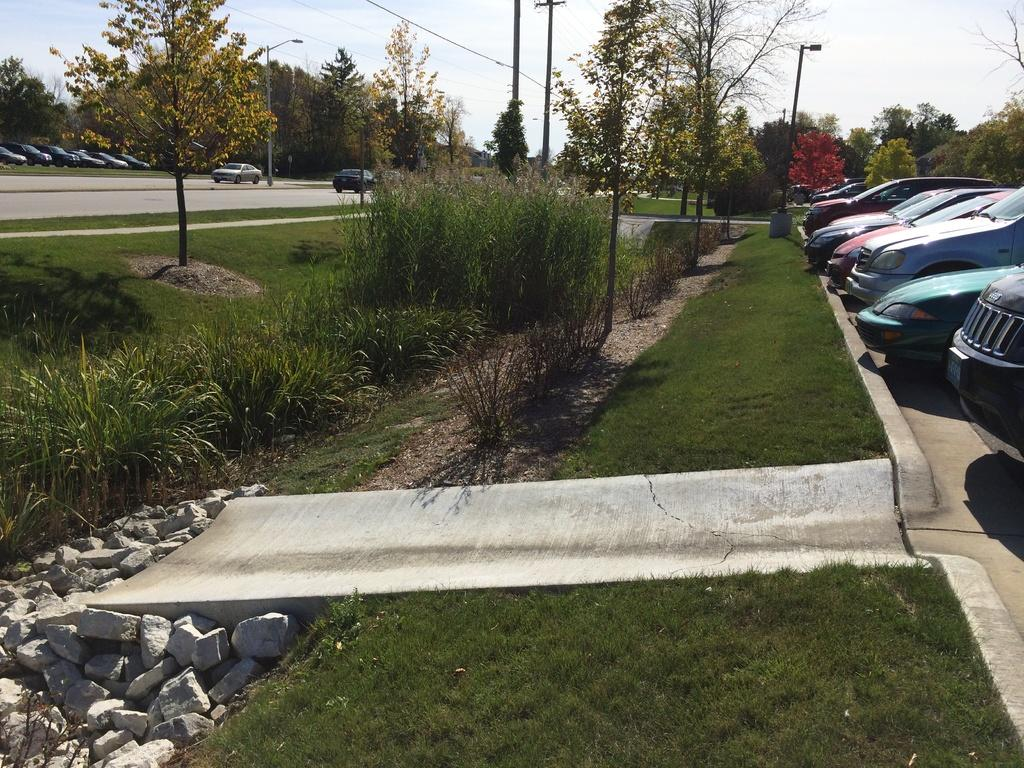What type of vehicles can be seen on the road in the image? There are cars on the road in the image. What natural elements are present in the image? There are trees, grass, and stones in the image. What man-made structures can be seen in the image? There are poles in the image. What is visible in the background of the image? The sky is visible in the background of the image. Can you tell me how many owls are sitting on the poles in the image? There are no owls present in the image; only cars, trees, grass, stones, poles, and the sky are visible. What type of paper is being used to cover the trees in the image? There is no paper present in the image, and the trees are not covered. 